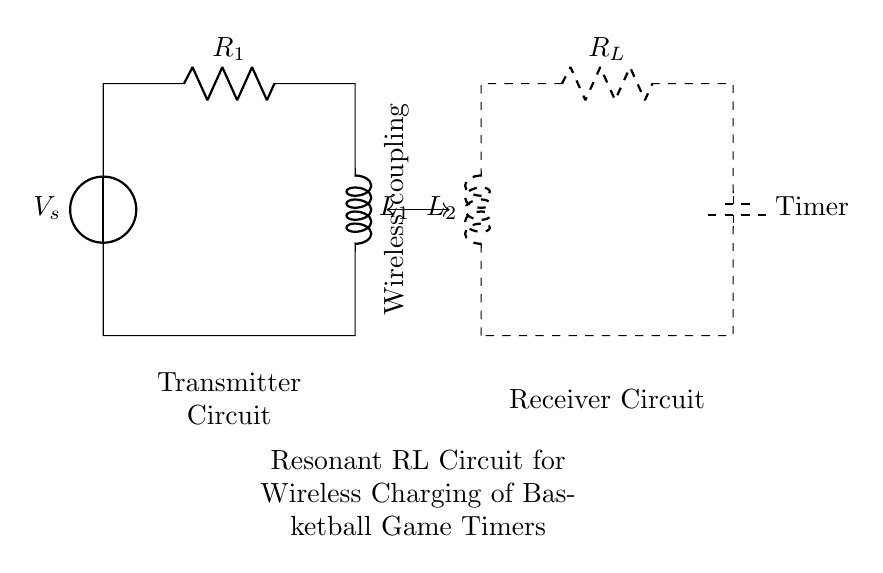What is the source voltage in the circuit? The source voltage is denoted as V_s at the top left corner of the circuit diagram, indicating the external power supply connected to the circuit.
Answer: V_s What are the values of the resistors in the circuit? In the circuit diagram, there are two resistors labeled: R_1 in the transmitter circuit, and R_L in the receiver circuit. Their specific numerical values are not indicated, but their identifiers are visible.
Answer: R_1 and R_L What type of coupling is depicted in this circuit? The diagram includes a dashed line with a label indicating wireless coupling between the transmitter and receiver circuits, which is essential for the operation of this wireless charging system.
Answer: Wireless coupling How many components are in the transmitter circuit? The transmitter circuit consists of three main components: the voltage source V_s, the resistor R_1, and the inductor L_1. Counting these gives a total of three components.
Answer: Three What is the function of the inductor L_1 in the circuit? In resonant circuits, inductors store energy in a magnetic field, which allows for the generation of oscillations that can create the desired resonant frequency necessary for efficient energy transfer.
Answer: Energy storage What is the role of R_L in the receiver circuit? The load resistor R_L is intended to dissipate energy transferred wirelessly, converting it into usable power for the attached basketball game timer, thus allowing it to function as intended.
Answer: Energy dissipation What type of circuit is shown here? The circuit depicted is a resonant RL circuit designed for wireless charging, combining both resistive and inductive elements to achieve resonance for efficient power transfer.
Answer: Resonant RL circuit 